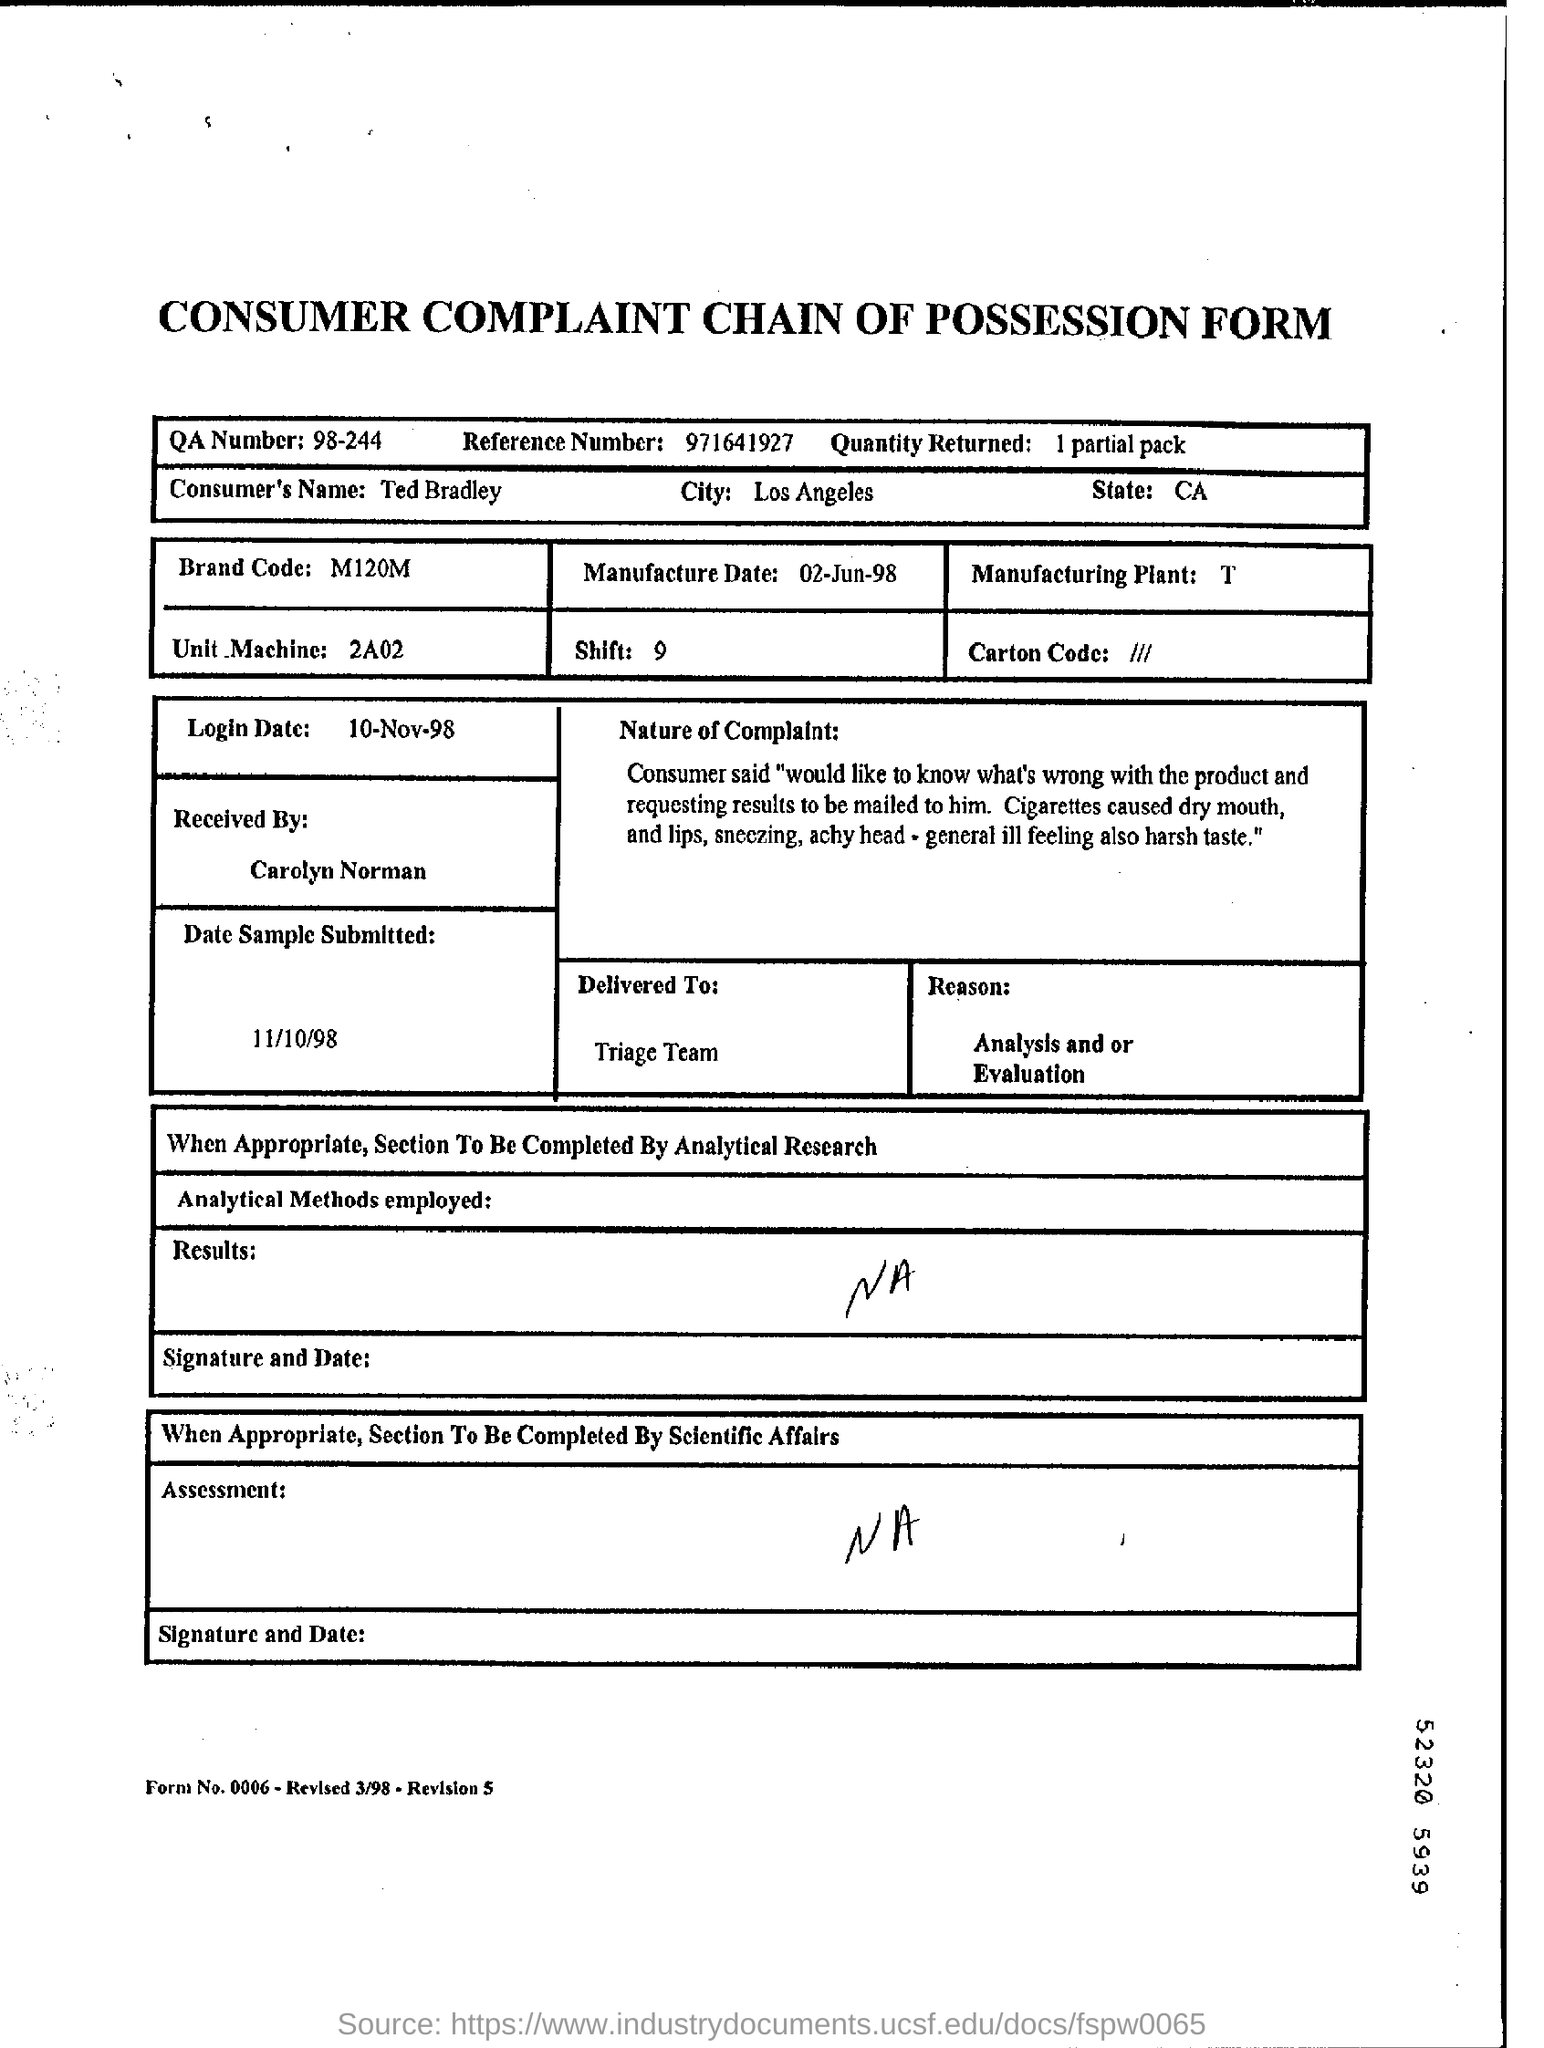Outline some significant characteristics in this image. The QA number is 98-244. The complaint was received by Carolyn Norman. The reference number given is 971641927. The brand code was M120M.. The reason given in the passage is that the author has claimed that the article titled "How to Use LinkedIn for Recruiters" is a joke, but the author does not provide any specific reason or evidence to support this claim. The author also provides an analysis and evaluation of the article, claiming that it is poorly written and that the author is not a recruiter. 